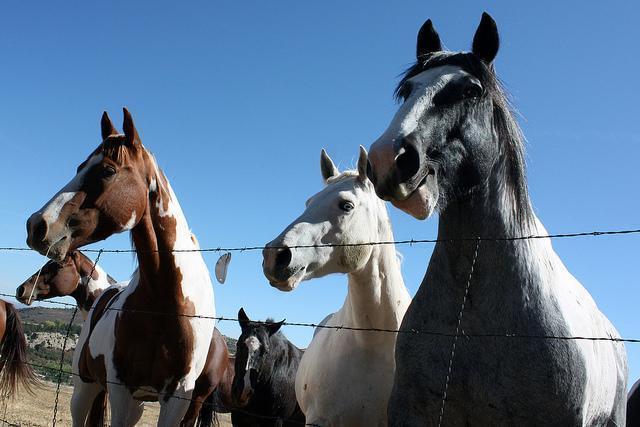What kind of fencing is used around these horses to keep them confined?
Choose the correct response, then elucidate: 'Answer: answer
Rationale: rationale.'
Options: Iron, link, electrified, wood. Answer: electrified.
Rationale: The fencing consists of wires, not links. the fencing is not made out of wood or iron. 